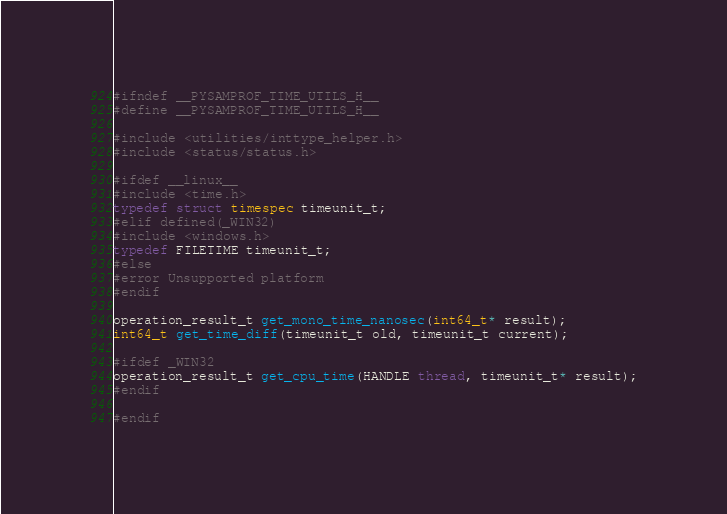Convert code to text. <code><loc_0><loc_0><loc_500><loc_500><_C_>#ifndef __PYSAMPROF_TIME_UTILS_H__
#define __PYSAMPROF_TIME_UTILS_H__

#include <utilities/inttype_helper.h>
#include <status/status.h>

#ifdef __linux__
#include <time.h>
typedef struct timespec timeunit_t;
#elif defined(_WIN32)
#include <windows.h>
typedef FILETIME timeunit_t;
#else
#error Unsupported platform
#endif

operation_result_t get_mono_time_nanosec(int64_t* result);
int64_t get_time_diff(timeunit_t old, timeunit_t current);

#ifdef _WIN32
operation_result_t get_cpu_time(HANDLE thread, timeunit_t* result);
#endif

#endif
</code> 